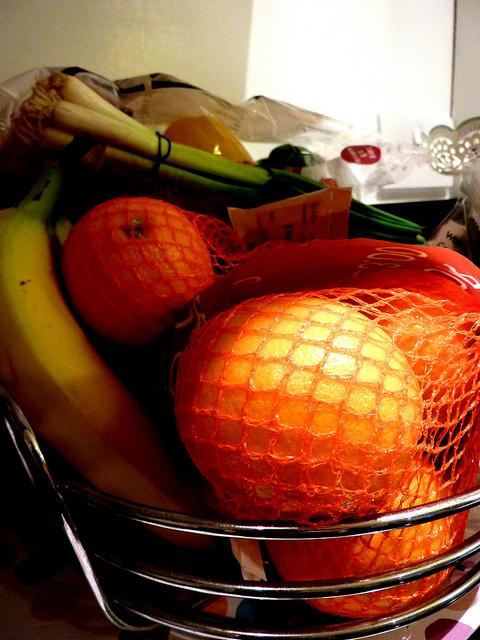What vegetable is bundled together? oranges 